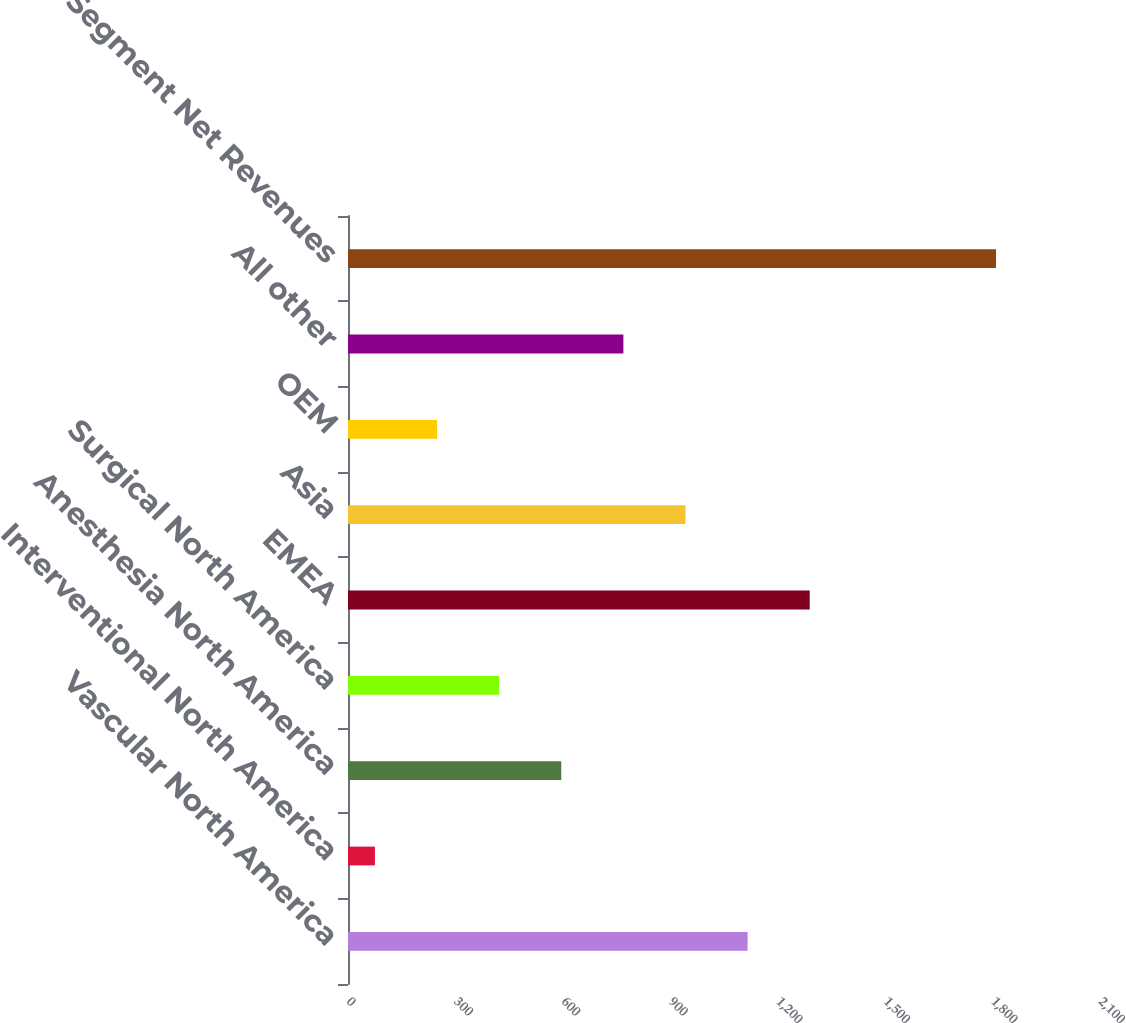Convert chart. <chart><loc_0><loc_0><loc_500><loc_500><bar_chart><fcel>Vascular North America<fcel>Interventional North America<fcel>Anesthesia North America<fcel>Surgical North America<fcel>EMEA<fcel>Asia<fcel>OEM<fcel>All other<fcel>Segment Net Revenues<nl><fcel>1115.9<fcel>75.2<fcel>595.55<fcel>422.1<fcel>1289.35<fcel>942.45<fcel>248.65<fcel>769<fcel>1809.7<nl></chart> 